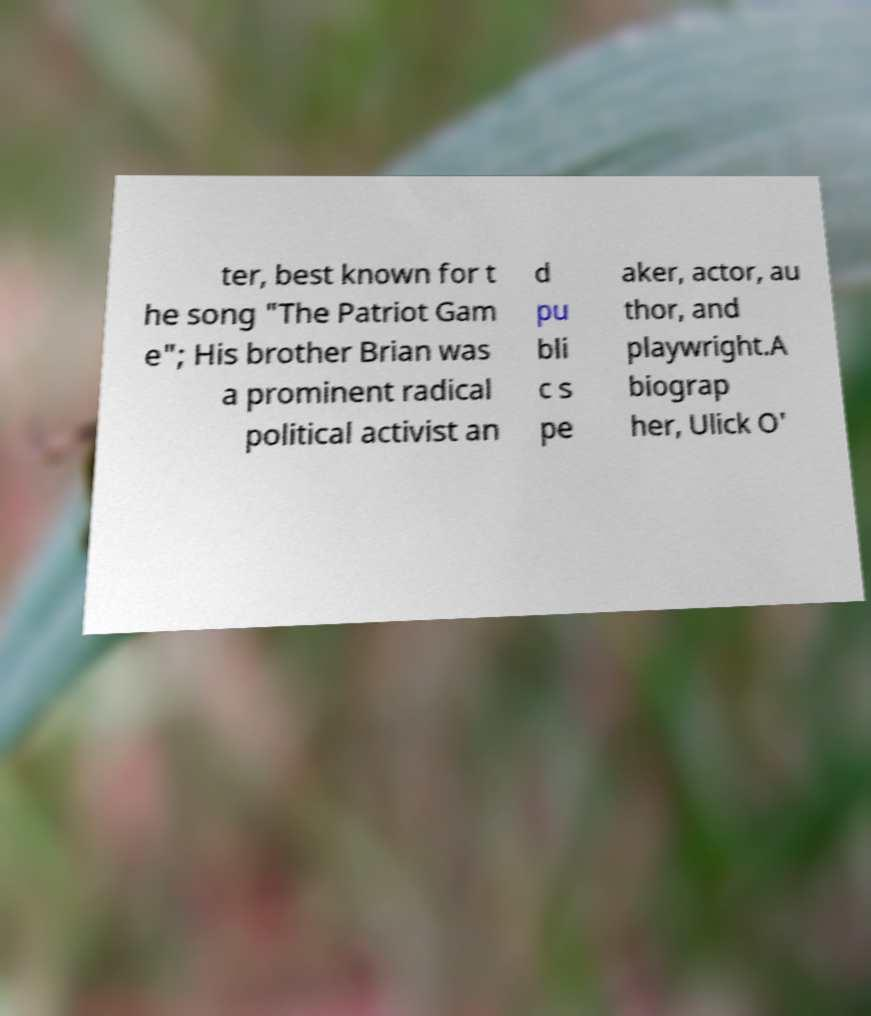Please identify and transcribe the text found in this image. ter, best known for t he song "The Patriot Gam e"; His brother Brian was a prominent radical political activist an d pu bli c s pe aker, actor, au thor, and playwright.A biograp her, Ulick O' 